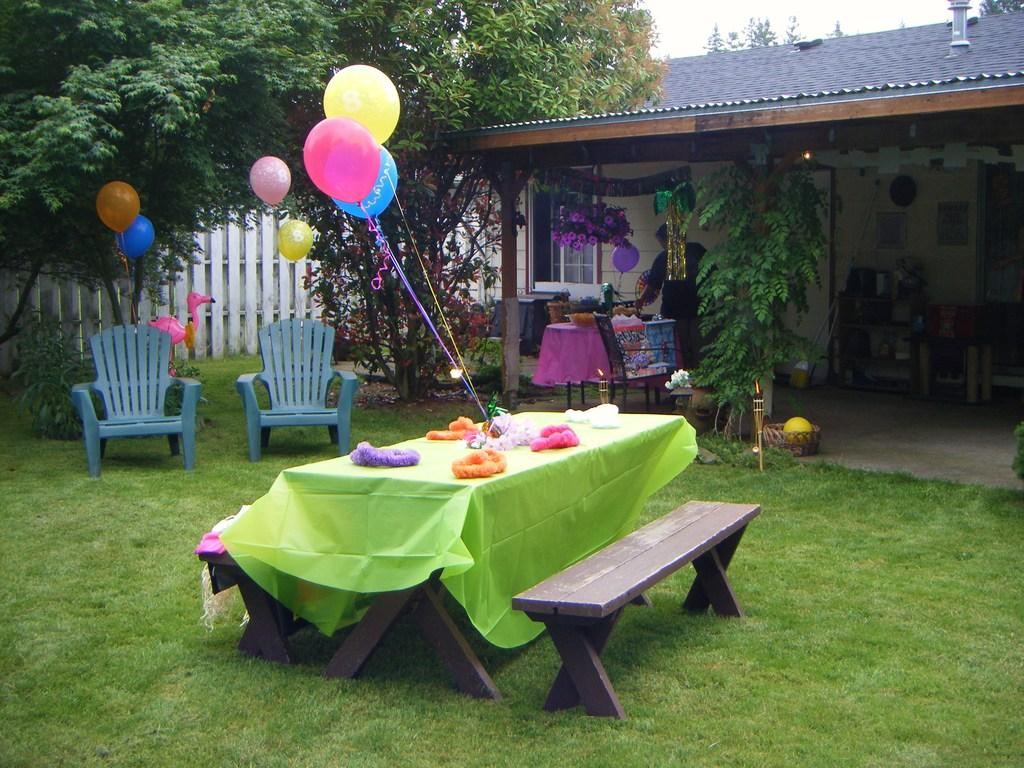What type of vegetation can be seen in the image? There are trees in the image. What structure is visible in the image? There is a house in the image. What part of the house is visible in the image? There is a roof in the image. What type of lighting is present in the image? There is a lamp in the image. What type of furniture is present in the image? There are chairs and tables in the image. What decorative items are on the table in the image? There are balloons on the table in the image. How many feet are visible in the image? There are no feet visible in the image. What type of pot is used to cook the food in the image? There is no pot or food present in the image. 